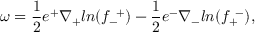<formula> <loc_0><loc_0><loc_500><loc_500>\omega = { \frac { 1 } { 2 } } e ^ { + } \nabla _ { + } \ln ( f _ { - } ^ { + } ) - { \frac { 1 } { 2 } } e ^ { - } \nabla _ { - } \ln ( f _ { + } ^ { - } ) ,</formula> 